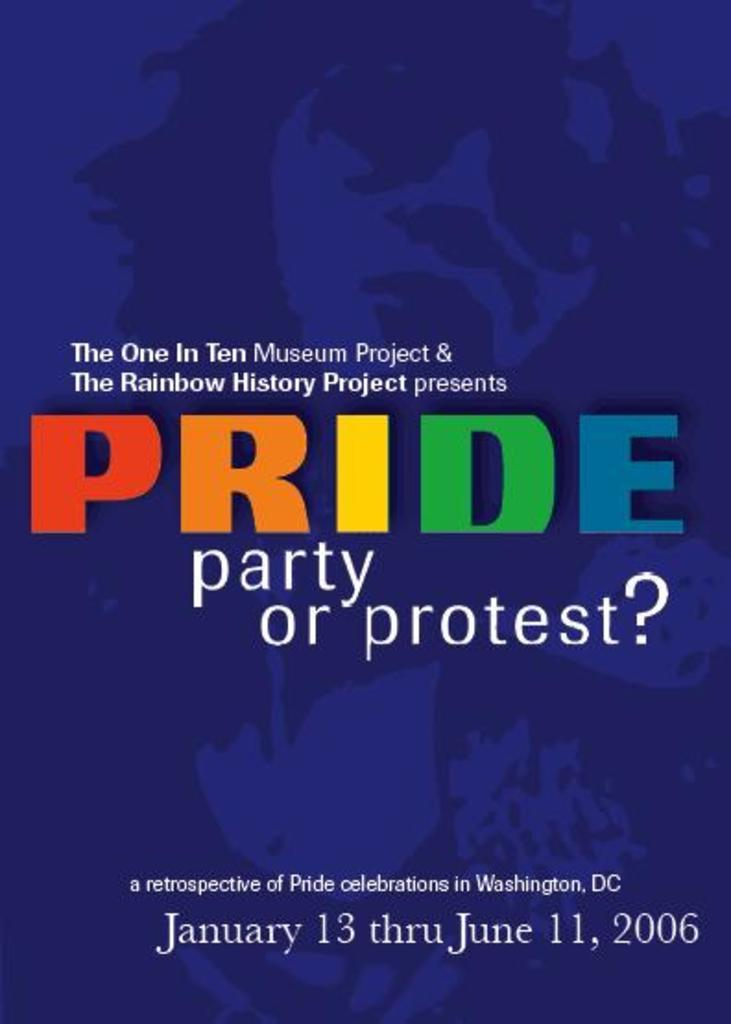<image>
Summarize the visual content of the image. A flyer advertising a retrospective of the Pride celebrations in Washington, D.C. 